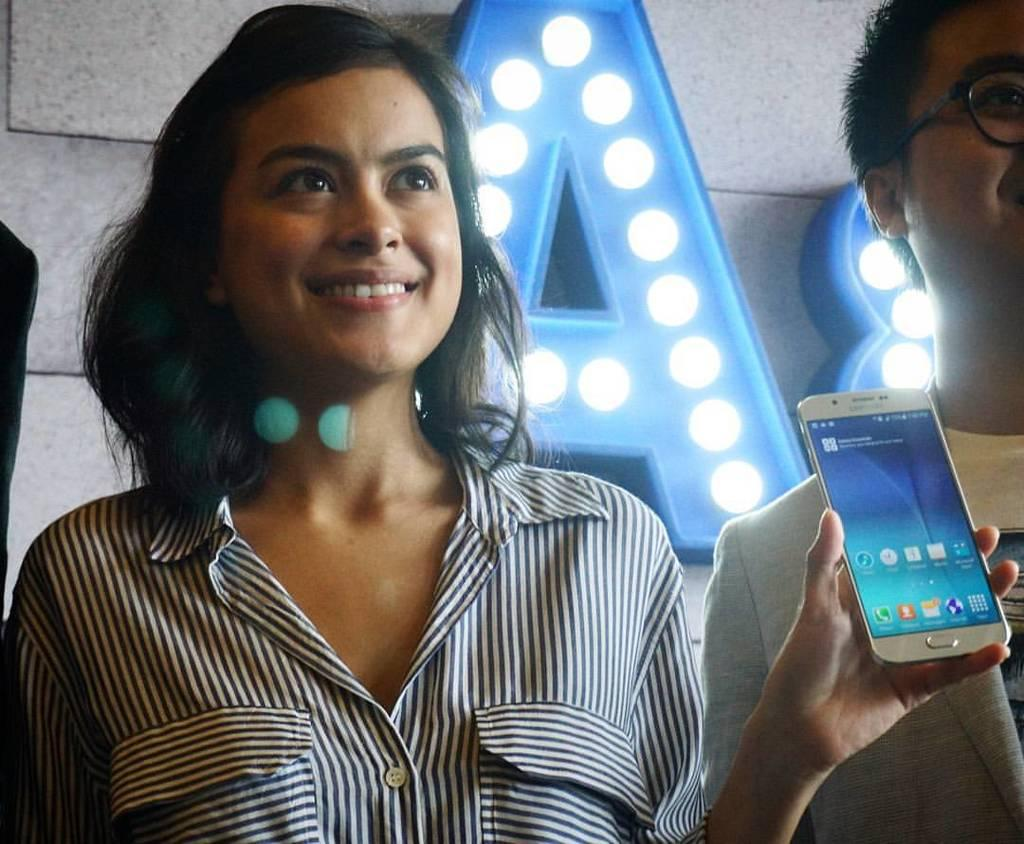Who is the main subject in the image? There is a lady in the image. What is the lady wearing? The lady is wearing a black and white shirt. What is the lady holding in her hand? The lady is holding a phone in her left hand. What type of land can be seen in the background of the image? There is no land visible in the image; it only features the lady and her phone. How does the phone generate friction with the lady's hand? The phone does not generate friction with the lady's hand in the image; it is simply being held by her. 